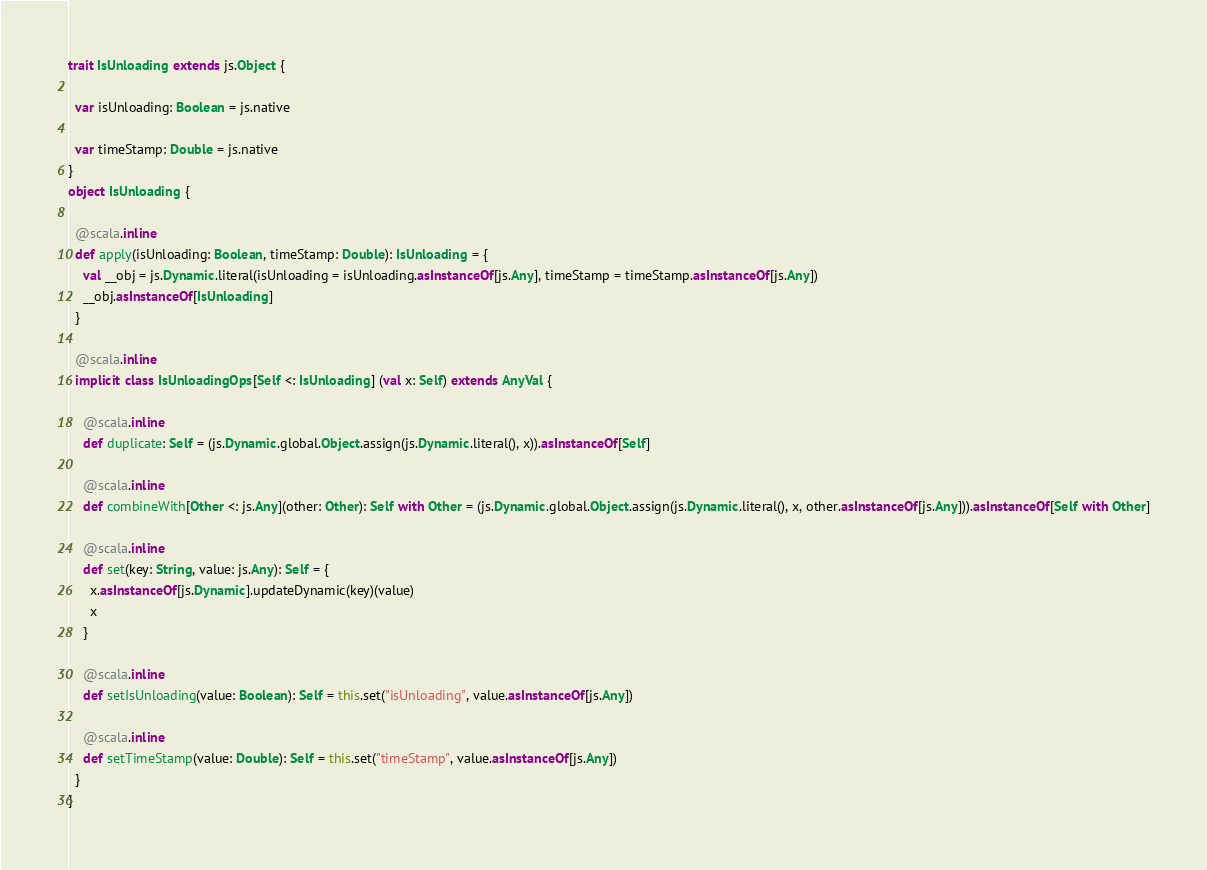<code> <loc_0><loc_0><loc_500><loc_500><_Scala_>trait IsUnloading extends js.Object {
  
  var isUnloading: Boolean = js.native
  
  var timeStamp: Double = js.native
}
object IsUnloading {
  
  @scala.inline
  def apply(isUnloading: Boolean, timeStamp: Double): IsUnloading = {
    val __obj = js.Dynamic.literal(isUnloading = isUnloading.asInstanceOf[js.Any], timeStamp = timeStamp.asInstanceOf[js.Any])
    __obj.asInstanceOf[IsUnloading]
  }
  
  @scala.inline
  implicit class IsUnloadingOps[Self <: IsUnloading] (val x: Self) extends AnyVal {
    
    @scala.inline
    def duplicate: Self = (js.Dynamic.global.Object.assign(js.Dynamic.literal(), x)).asInstanceOf[Self]
    
    @scala.inline
    def combineWith[Other <: js.Any](other: Other): Self with Other = (js.Dynamic.global.Object.assign(js.Dynamic.literal(), x, other.asInstanceOf[js.Any])).asInstanceOf[Self with Other]
    
    @scala.inline
    def set(key: String, value: js.Any): Self = {
      x.asInstanceOf[js.Dynamic].updateDynamic(key)(value)
      x
    }
    
    @scala.inline
    def setIsUnloading(value: Boolean): Self = this.set("isUnloading", value.asInstanceOf[js.Any])
    
    @scala.inline
    def setTimeStamp(value: Double): Self = this.set("timeStamp", value.asInstanceOf[js.Any])
  }
}
</code> 